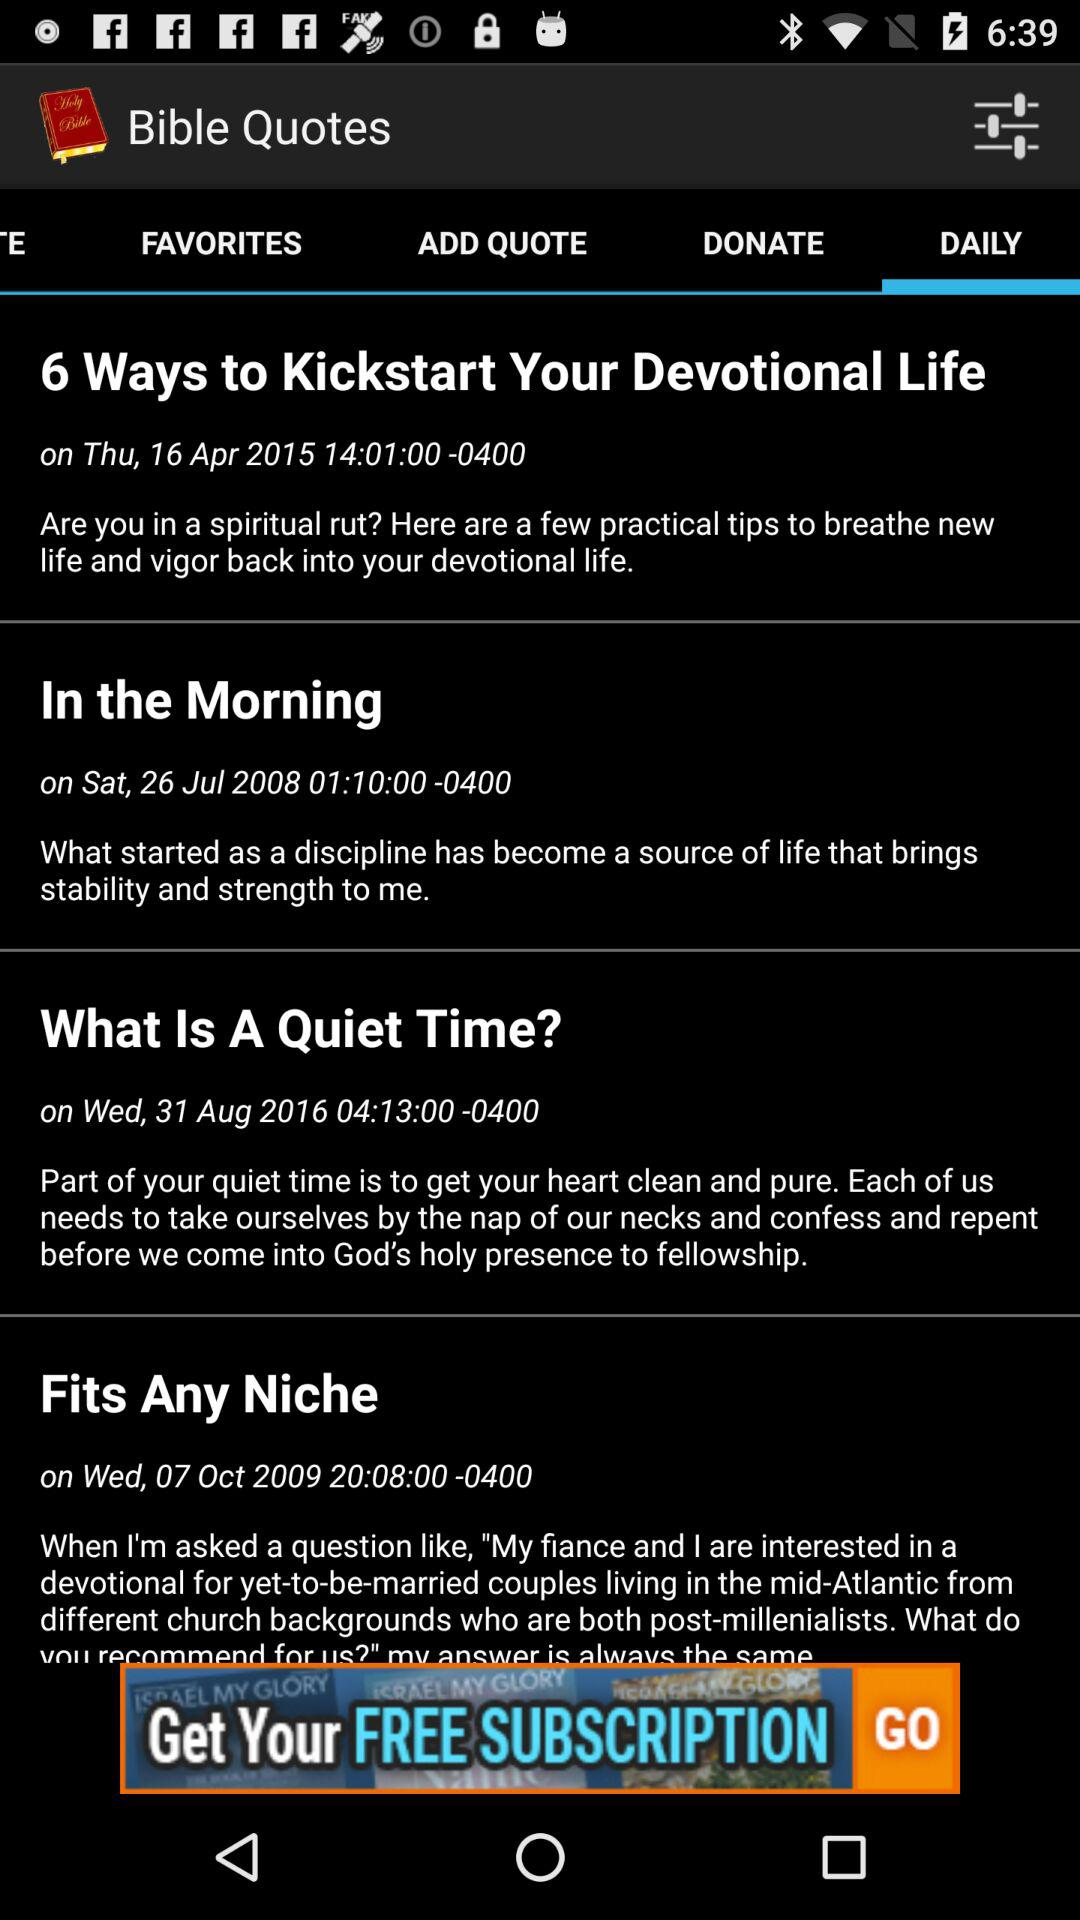When was the "In the Morning" quote updated? "In the Morning" quote was updated on Saturday, July 26, 2008 at 01:10:00. 